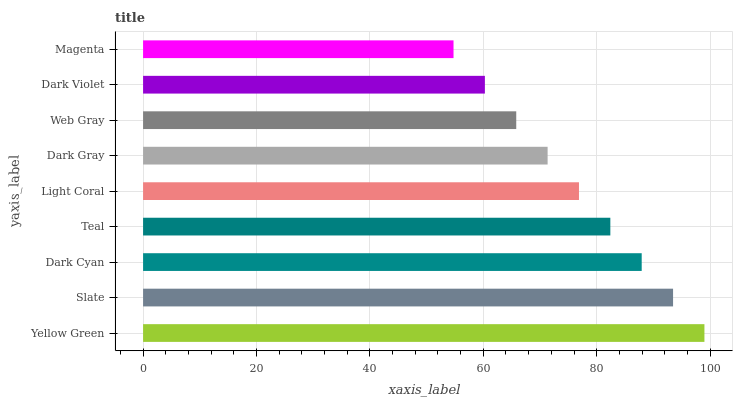Is Magenta the minimum?
Answer yes or no. Yes. Is Yellow Green the maximum?
Answer yes or no. Yes. Is Slate the minimum?
Answer yes or no. No. Is Slate the maximum?
Answer yes or no. No. Is Yellow Green greater than Slate?
Answer yes or no. Yes. Is Slate less than Yellow Green?
Answer yes or no. Yes. Is Slate greater than Yellow Green?
Answer yes or no. No. Is Yellow Green less than Slate?
Answer yes or no. No. Is Light Coral the high median?
Answer yes or no. Yes. Is Light Coral the low median?
Answer yes or no. Yes. Is Yellow Green the high median?
Answer yes or no. No. Is Teal the low median?
Answer yes or no. No. 